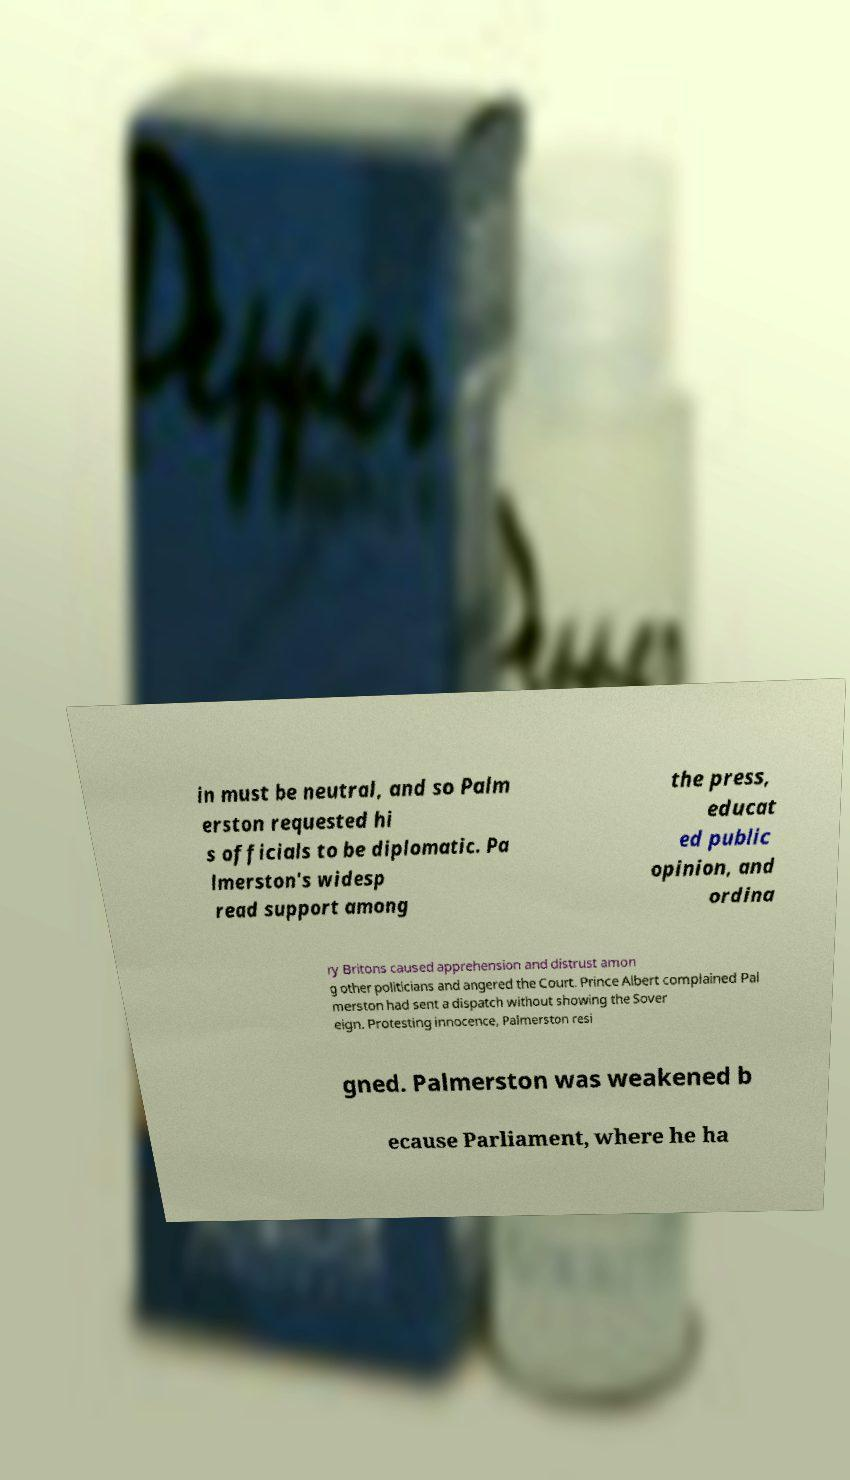For documentation purposes, I need the text within this image transcribed. Could you provide that? in must be neutral, and so Palm erston requested hi s officials to be diplomatic. Pa lmerston's widesp read support among the press, educat ed public opinion, and ordina ry Britons caused apprehension and distrust amon g other politicians and angered the Court. Prince Albert complained Pal merston had sent a dispatch without showing the Sover eign. Protesting innocence, Palmerston resi gned. Palmerston was weakened b ecause Parliament, where he ha 